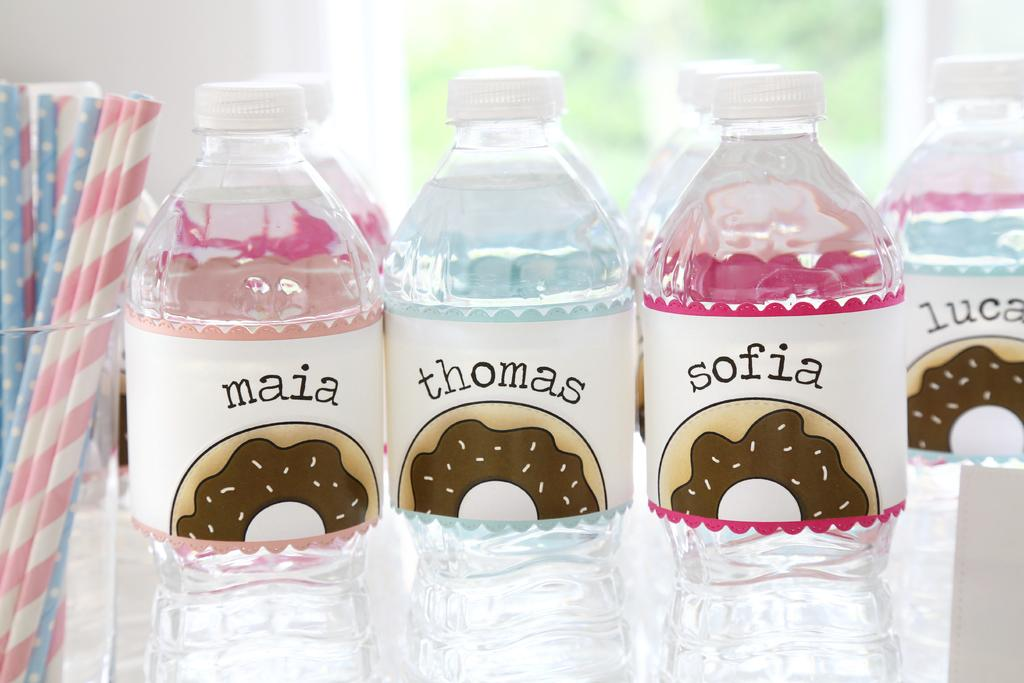Provide a one-sentence caption for the provided image. A display of plastic bottles with labels that have children's names and a picture of a donut while there is a glass of paper straws next to them. 